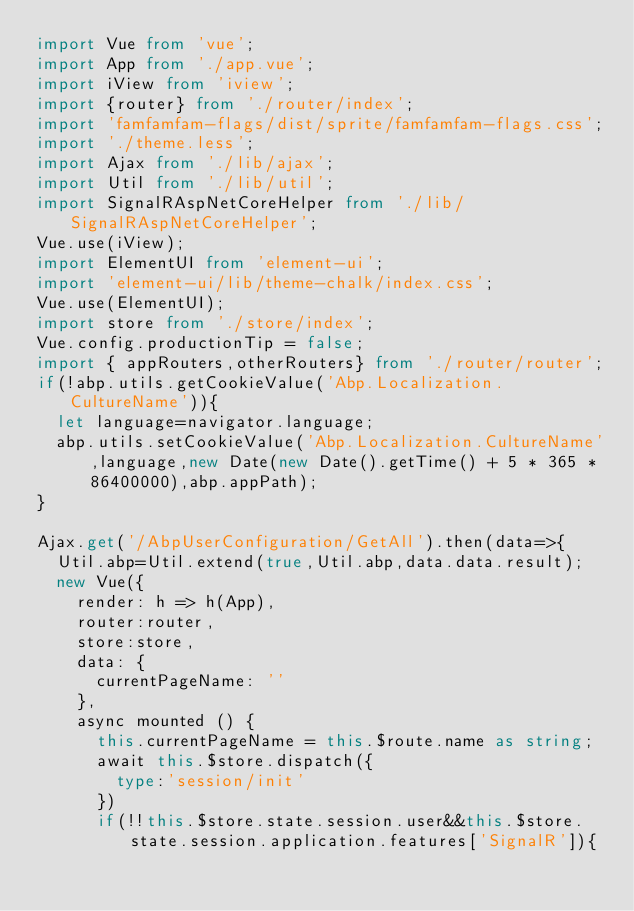Convert code to text. <code><loc_0><loc_0><loc_500><loc_500><_TypeScript_>import Vue from 'vue';
import App from './app.vue';
import iView from 'iview';
import {router} from './router/index';
import 'famfamfam-flags/dist/sprite/famfamfam-flags.css';
import './theme.less';
import Ajax from './lib/ajax';
import Util from './lib/util';
import SignalRAspNetCoreHelper from './lib/SignalRAspNetCoreHelper';
Vue.use(iView);
import ElementUI from 'element-ui';
import 'element-ui/lib/theme-chalk/index.css';
Vue.use(ElementUI);
import store from './store/index';
Vue.config.productionTip = false;
import { appRouters,otherRouters} from './router/router';
if(!abp.utils.getCookieValue('Abp.Localization.CultureName')){
  let language=navigator.language;
  abp.utils.setCookieValue('Abp.Localization.CultureName',language,new Date(new Date().getTime() + 5 * 365 * 86400000),abp.appPath);
}

Ajax.get('/AbpUserConfiguration/GetAll').then(data=>{
  Util.abp=Util.extend(true,Util.abp,data.data.result);
  new Vue({
    render: h => h(App),
    router:router,
    store:store,
    data: {
      currentPageName: ''
    },
    async mounted () {
      this.currentPageName = this.$route.name as string;
      await this.$store.dispatch({
        type:'session/init'
      })
      if(!!this.$store.state.session.user&&this.$store.state.session.application.features['SignalR']){</code> 